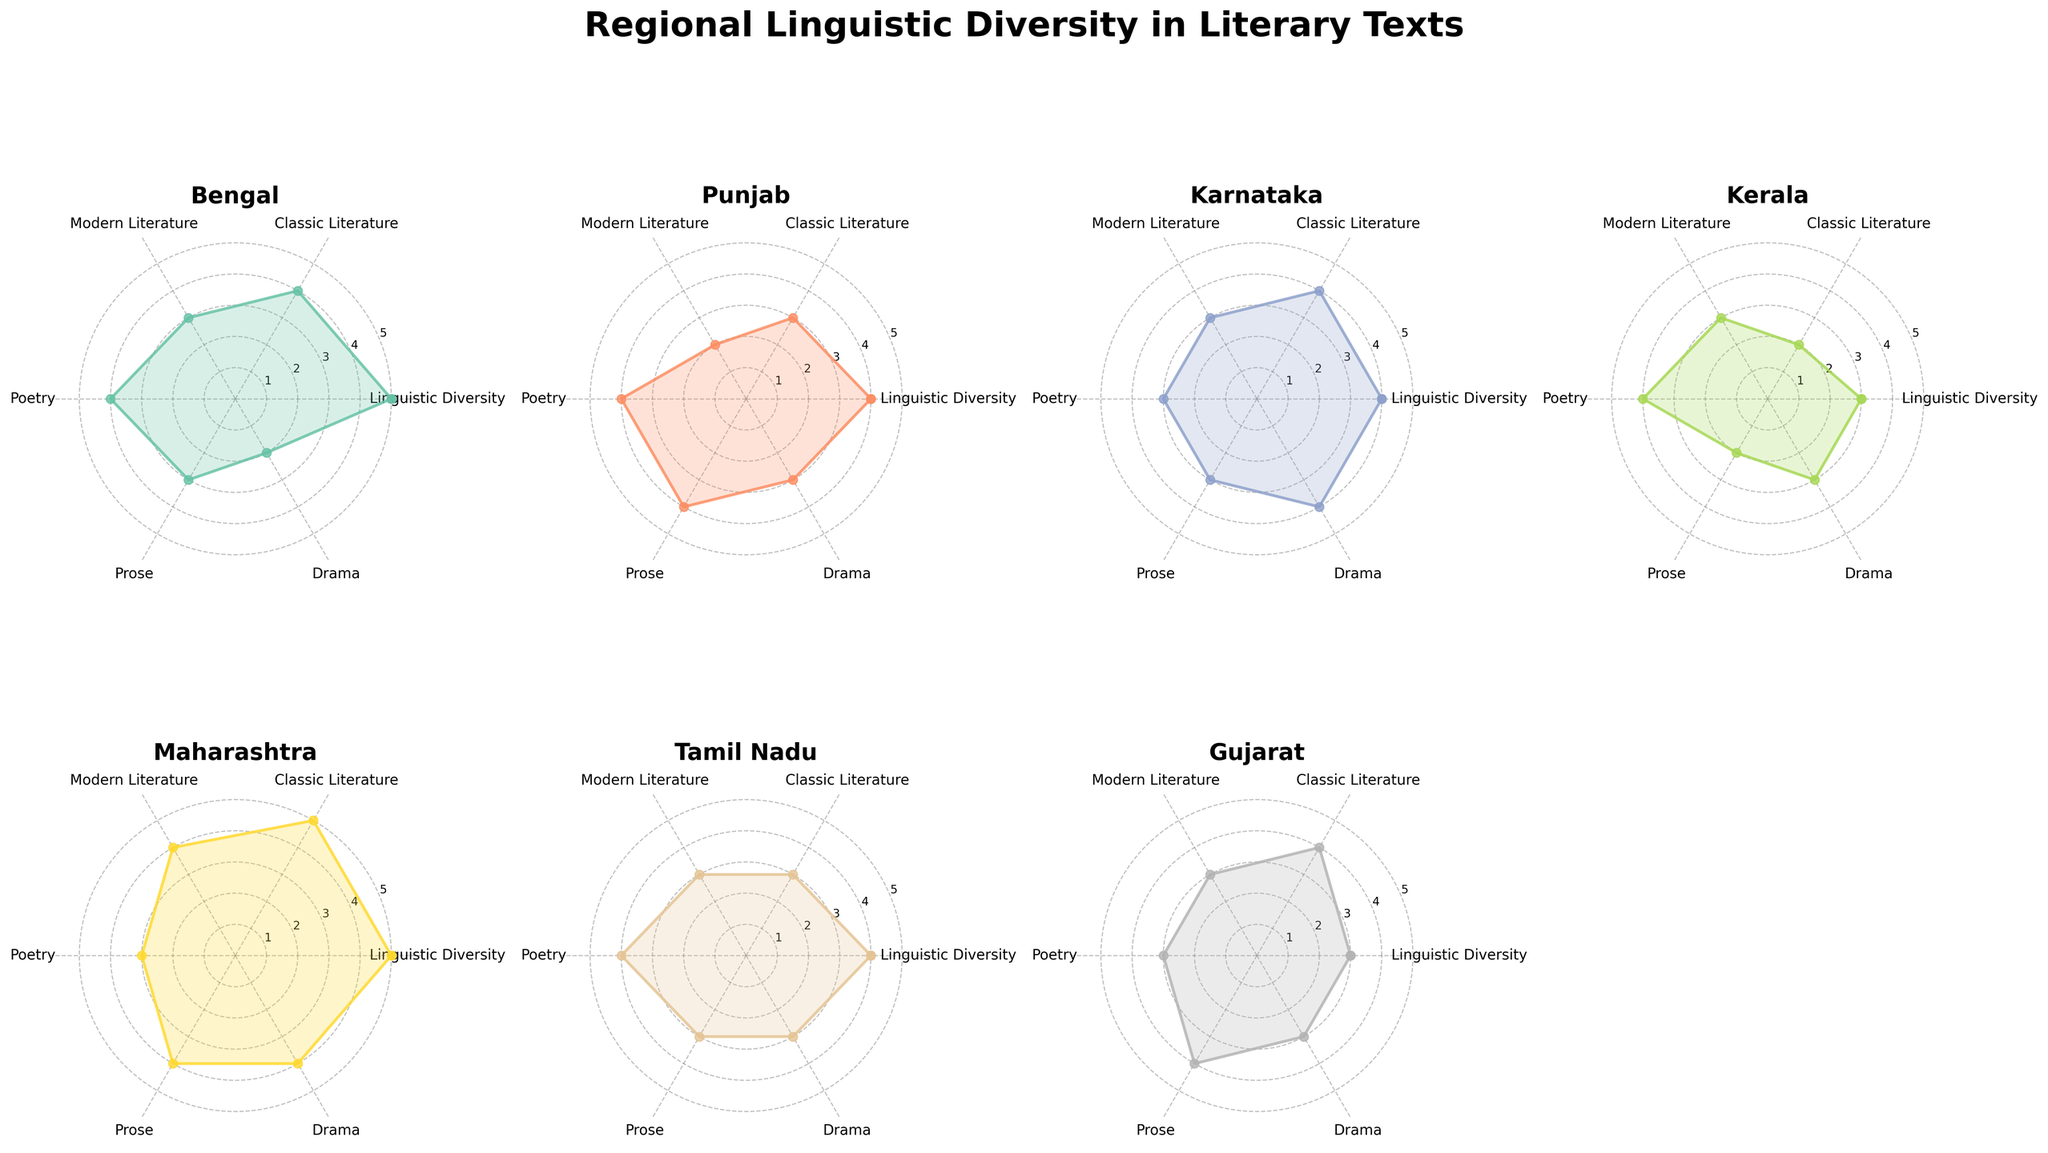Which region shows the highest value in the "Drama" category? The highest value is the region with the highest point along the "Drama" axis. By looking at the charts, Maharashtra has the highest value of 4 in Drama.
Answer: Maharashtra Which region has the lowest linguistic diversity score? The region with the lowest linguistic diversity score will have the smallest value on the "Linguistic Diversity" axis. Kerala shows the lowest value of 2 in linguistic diversity.
Answer: Kerala Which two regions have equal values in the "Prose" category? By inspecting the charts, Bengal and Kerala both have a score of 4 in the Prose category.
Answer: Bengal and Punjab What's the average score of Gujarat in all categories? Sum up Gujarat's values across all categories and then divide by the number of categories: (3+4+3+3+4+3)/6 = 20/6 ≈ 3.33
Answer: 3.33 How does Karnataka's performance in "Classic Literature" compare to Tamil Nadu's? Karnataka and Tamil Nadu both have a value of 4 in Classic Literature, making them equal in this category.
Answer: Equal Which region demonstrates the greatest range of values across all categories? Compute the range for each region and compare: Bengal: 4-2=2, Punjab: 4-2=2, Karnataka: 4-1=3, Kerala: 4-2=2, Maharashtra: 5-2=3, Tamil Nadu: 4-2=2, Gujarat: 4-2=2. Karnataka and Maharashtra both have a range of 3, the highest.
Answer: Karnataka and Maharashtra Based on the radar chart, which region has consistently high values without extreme low points? Comparing each region's radar plot, Maharashtra has consistently high values, with no category lower than 3.
Answer: Maharashtra What is the combined score for Kerala in "Modern Literature" and "Poetry"? Add the scores of Kerala for Modern Literature and Poetry: 2+3 = 5
Answer: 5 In the "Poetry" category, which region scores the lowest? Look at the "Poetry" axis on each chart. Punjab scores a 2, which is the lowest.
Answer: Punjab How many regions score 4 in "Drama"? Count the number of regions that have a score of 4 in the Drama category. Bengal, Karnataka, and Maharashtra all score 4.
Answer: 3 